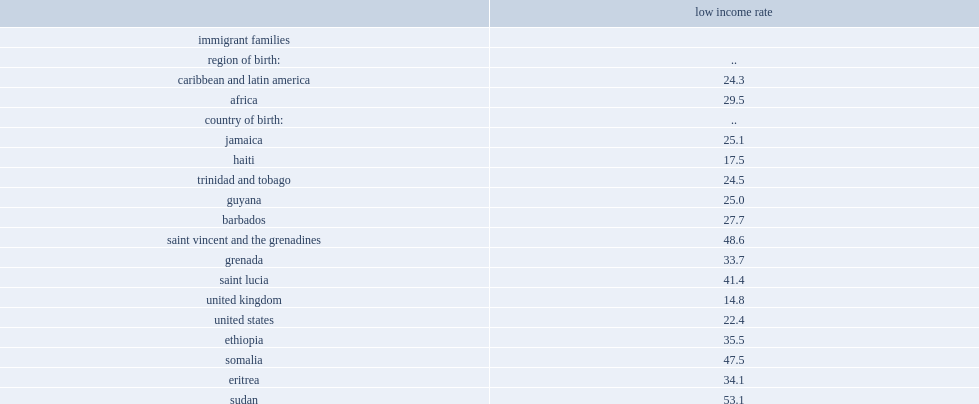List countries that had the low-income rates (mbm) above 30% among black children aged 0 to 14 in immigrant families in 2015. Ethiopia saint vincent and the grenadines grenada saint lucia somalia eritrea sudan south sudan. How many percent of children from sudanese immigrant families is affected by low-income status (mbm)? 53.1. Could you parse the entire table as a dict? {'header': ['', 'low income rate'], 'rows': [['immigrant families', ''], ['region of birth:', '..'], ['caribbean and latin america', '24.3'], ['africa', '29.5'], ['country of birth:', '..'], ['jamaica', '25.1'], ['haiti', '17.5'], ['trinidad and tobago', '24.5'], ['guyana', '25.0'], ['barbados', '27.7'], ['saint vincent and the grenadines', '48.6'], ['grenada', '33.7'], ['saint lucia', '41.4'], ['united kingdom', '14.8'], ['united states', '22.4'], ['ethiopia', '35.5'], ['somalia', '47.5'], ['eritrea', '34.1'], ['sudan', '53.1'], ['south sudan', '46.1'], ['burundi', '25.3'], ['kenya', '22.6'], ['zimbabwe', '18.7'], ['rwanda', '17.5'], ['democratic republic of the congo', '27.4'], ['cameroon', '13.3'], ['nigeria', '22.3'], ['ghana', '28.4'], ["cote d'ivoire", '13.2'], ['senegal', '10.9'], ['guinea', '21.0'], ['second- and third- generation-or-more families', ''], ['region of ancestry:', '..'], ['caribbean and latin america', '25.0'], ['africa', '27.0'], ['country of ancestry:', '..'], ['jamaica', '28.6'], ['haiti', '15.2'], ['trinidad and tobago', '21.6'], ['barbados', '18.3'], ['guyana', '28.2'], ['saint vincent and the grenadines', '22.2'], ['grenada', '24.0'], ['ghana', '33.1'], ['nigeria', '18.9'], ['united states', '35.2'], ['united kingdom', '32.1'], ['canada', '26.7']]} 